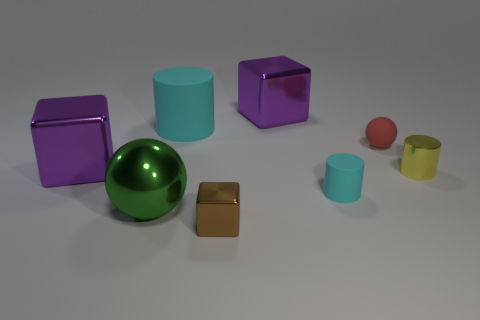Subtract all gray cubes. Subtract all gray spheres. How many cubes are left? 3 Add 1 large cyan matte cylinders. How many objects exist? 9 Subtract all balls. How many objects are left? 6 Add 1 large gray matte cubes. How many large gray matte cubes exist? 1 Subtract 1 brown cubes. How many objects are left? 7 Subtract all tiny cylinders. Subtract all tiny purple shiny balls. How many objects are left? 6 Add 4 small yellow metal things. How many small yellow metal things are left? 5 